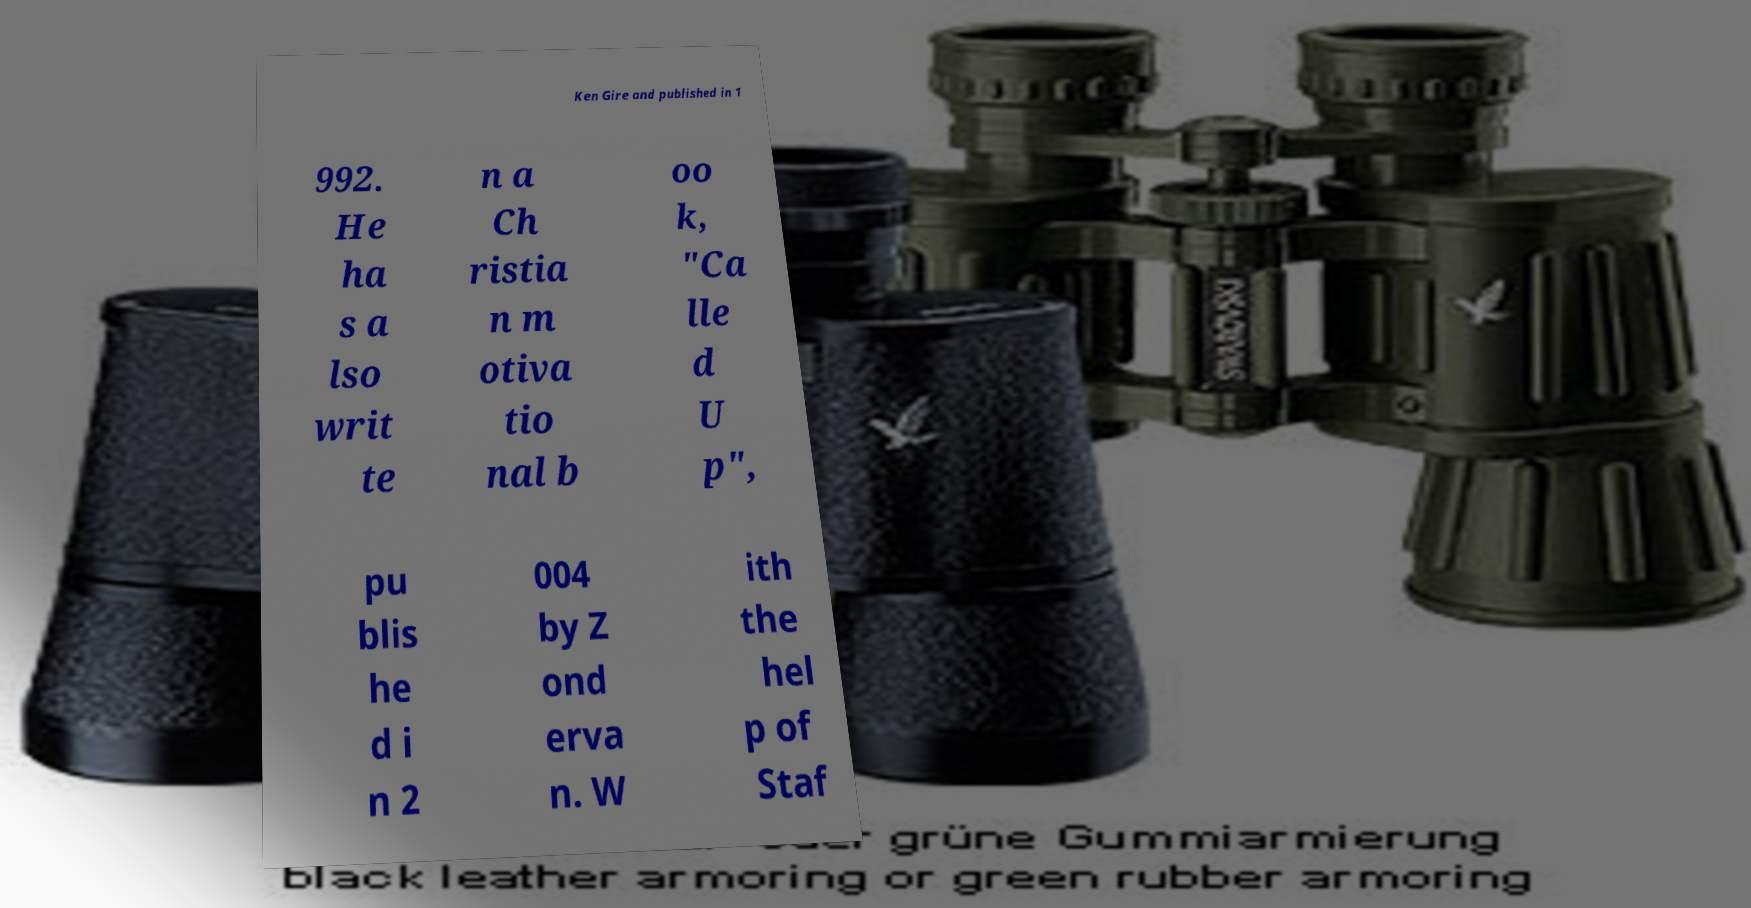Could you extract and type out the text from this image? Ken Gire and published in 1 992. He ha s a lso writ te n a Ch ristia n m otiva tio nal b oo k, "Ca lle d U p", pu blis he d i n 2 004 by Z ond erva n. W ith the hel p of Staf 